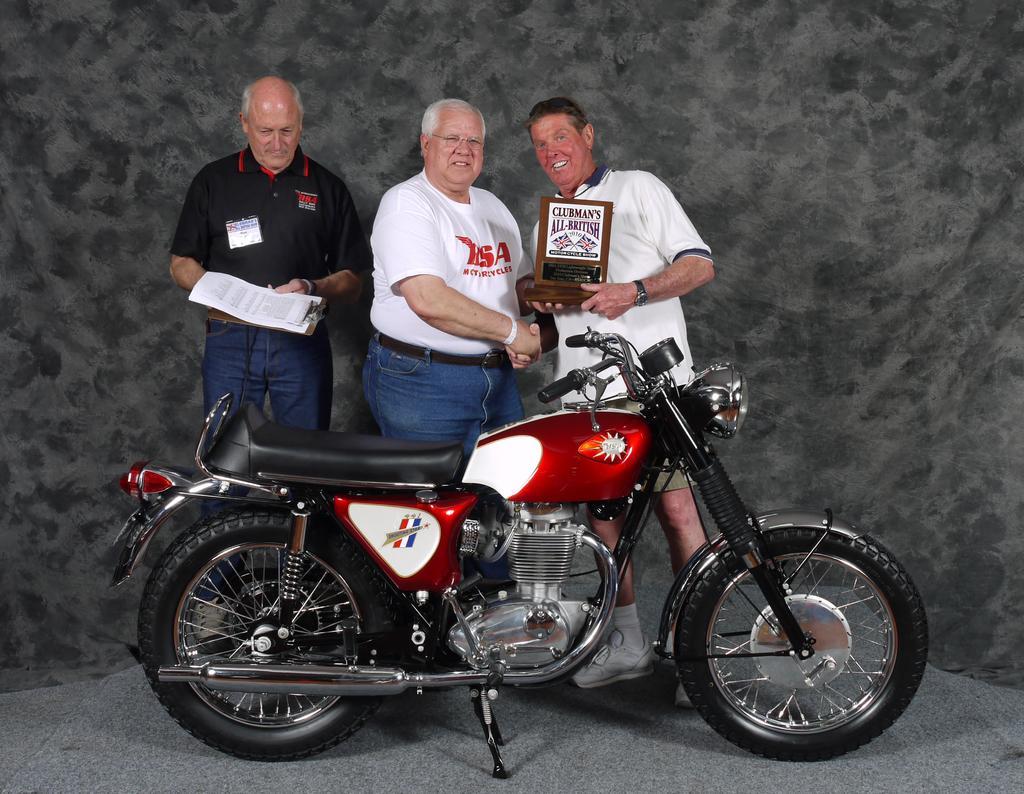How would you summarize this image in a sentence or two? In the middle an old man is standing, he wore a white color t-shirt. Beside him there is another man, who is smiling and in the left side a person is standing , he wore a black color t-shirt and this is a bike which is in red color. 